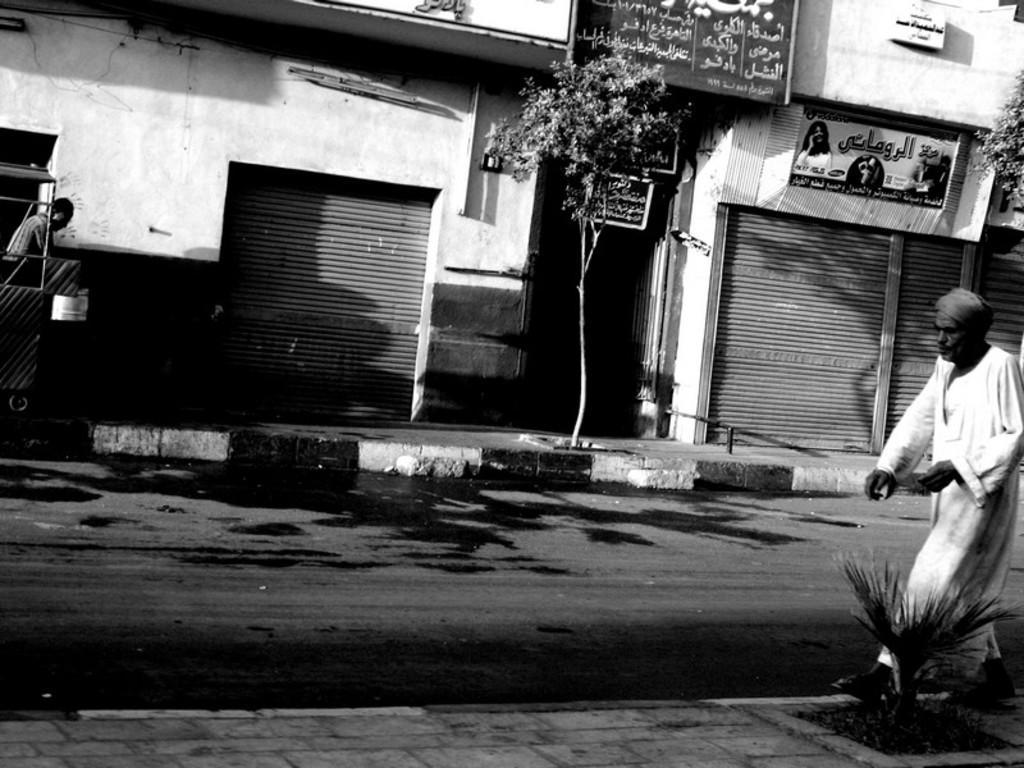In one or two sentences, can you explain what this image depicts? This is a black and white image , where there are two persons standing, there is road, there are shops, name boards , shutters and there are trees. 